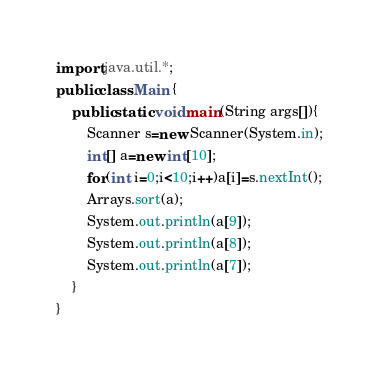<code> <loc_0><loc_0><loc_500><loc_500><_Java_>import java.util.*;
public class Main {
	public static void main(String args[]){
		Scanner s=new Scanner(System.in);
		int[] a=new int[10];
		for(int i=0;i<10;i++)a[i]=s.nextInt();
		Arrays.sort(a);
		System.out.println(a[9]);
		System.out.println(a[8]);
		System.out.println(a[7]);
	}
}</code> 